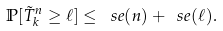Convert formula to latex. <formula><loc_0><loc_0><loc_500><loc_500>\mathbb { P } [ \tilde { T } ^ { n } _ { k } \geq \ell ] \leq \ s e ( n ) + \ s e ( \ell ) .</formula> 